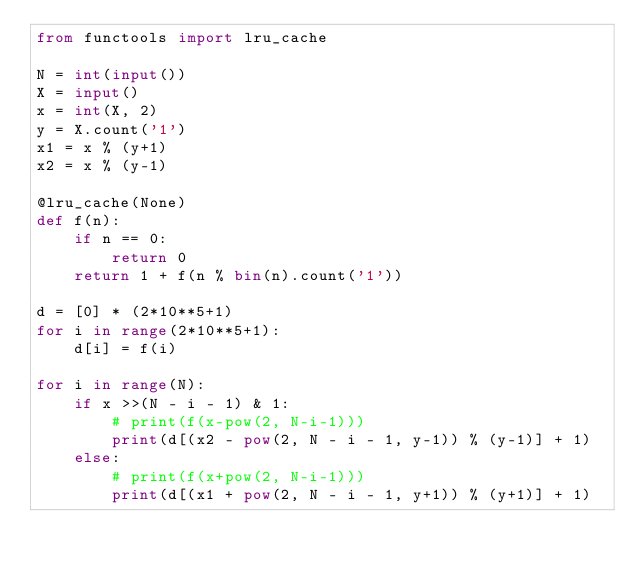<code> <loc_0><loc_0><loc_500><loc_500><_Python_>from functools import lru_cache

N = int(input())
X = input()
x = int(X, 2)
y = X.count('1')
x1 = x % (y+1)
x2 = x % (y-1)

@lru_cache(None)
def f(n):
    if n == 0:
        return 0
    return 1 + f(n % bin(n).count('1'))

d = [0] * (2*10**5+1)
for i in range(2*10**5+1):
    d[i] = f(i)

for i in range(N):
    if x >>(N - i - 1) & 1:
        # print(f(x-pow(2, N-i-1)))
        print(d[(x2 - pow(2, N - i - 1, y-1)) % (y-1)] + 1)
    else:
        # print(f(x+pow(2, N-i-1)))
        print(d[(x1 + pow(2, N - i - 1, y+1)) % (y+1)] + 1)</code> 